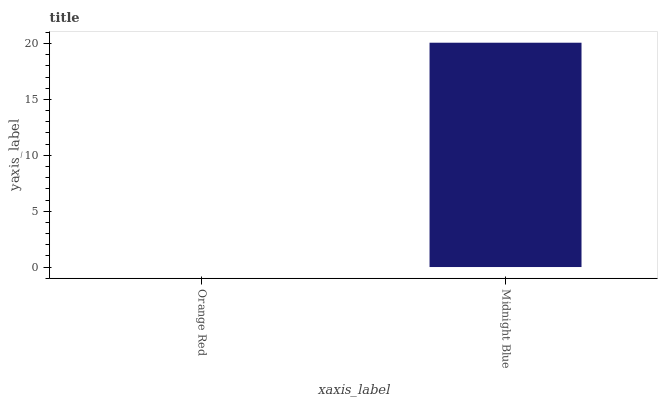Is Midnight Blue the minimum?
Answer yes or no. No. Is Midnight Blue greater than Orange Red?
Answer yes or no. Yes. Is Orange Red less than Midnight Blue?
Answer yes or no. Yes. Is Orange Red greater than Midnight Blue?
Answer yes or no. No. Is Midnight Blue less than Orange Red?
Answer yes or no. No. Is Midnight Blue the high median?
Answer yes or no. Yes. Is Orange Red the low median?
Answer yes or no. Yes. Is Orange Red the high median?
Answer yes or no. No. Is Midnight Blue the low median?
Answer yes or no. No. 